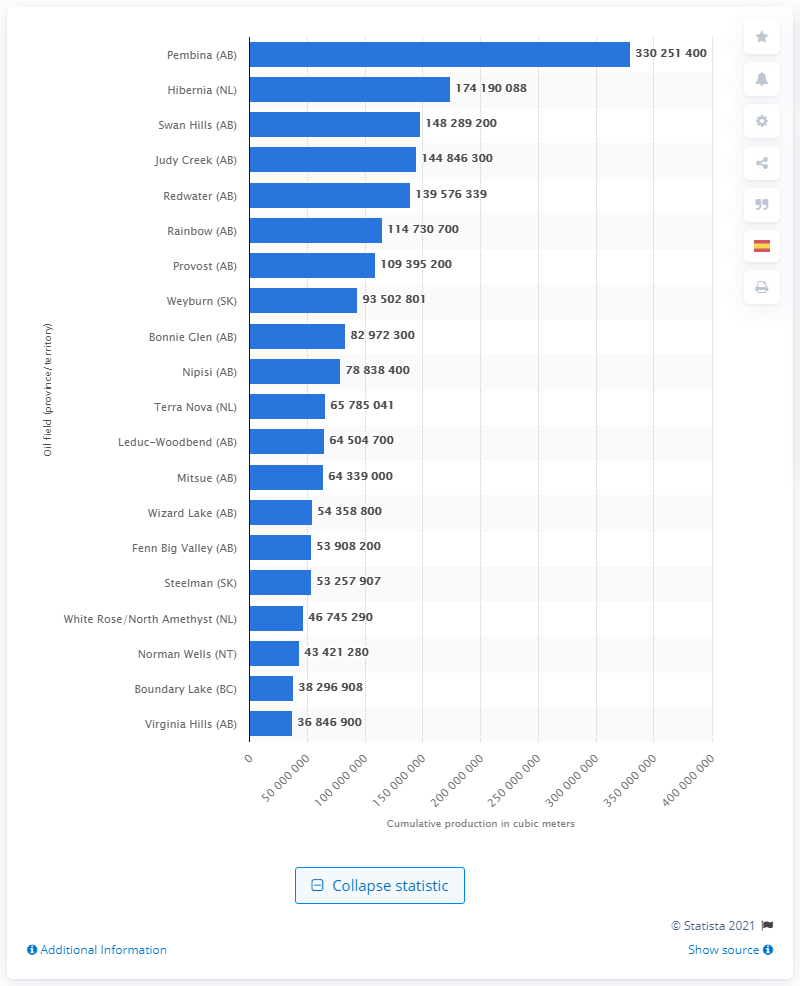Specify some key components in this picture. As of 2018, the Pembina oil field produced a total of 330,251,400 cubic meters of crude oil. 